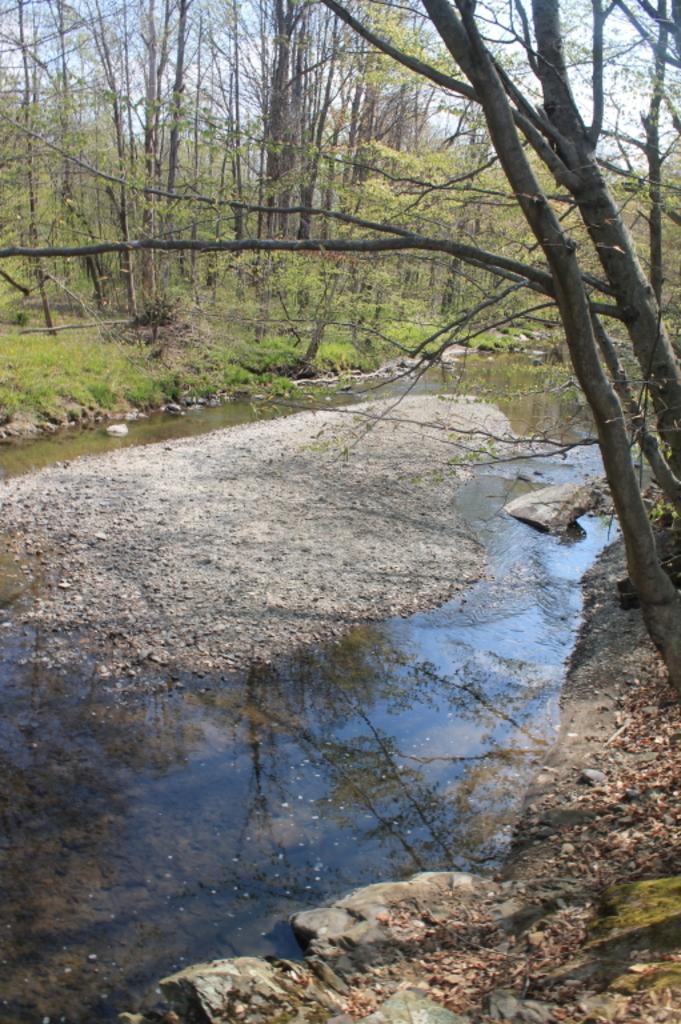Can you describe this image briefly? In this picture we can see land surrounded with water and beside the water there are trees, grass and above the tree there is sky and here we can see leaves. 